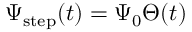<formula> <loc_0><loc_0><loc_500><loc_500>\Psi _ { s t e p } ( t ) = \Psi _ { 0 } \Theta ( t )</formula> 